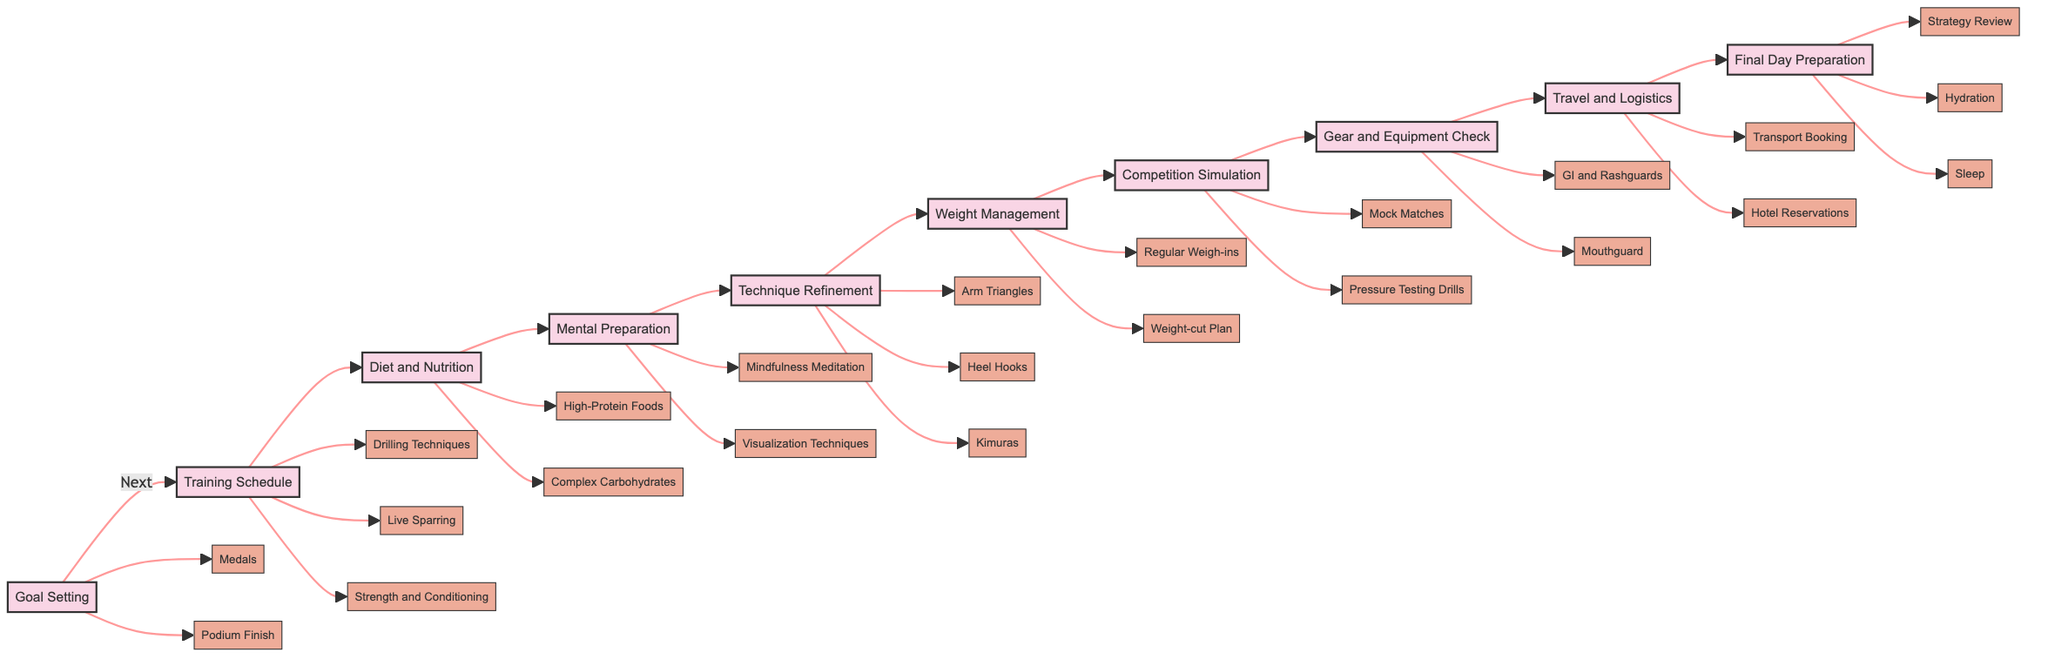What is the first step in preparing for a grappling tournament? The diagram indicates that the first step is "Goal Setting", as it is the initial node in the flowchart and leads to the next step, "Training Schedule".
Answer: Goal Setting How many main steps are represented in the diagram? By counting the nodes connected in the main flow, there are ten primary steps in total, from "Goal Setting" to "Final Day Preparation".
Answer: Ten What are examples of entities under Technique Refinement? The diagram lists three specific techniques under "Technique Refinement", namely "Arm Triangles", "Heel Hooks", and "Kimuras".
Answer: Arm Triangles, Heel Hooks, Kimuras Which steps come before and after Weight Management? The diagram shows that "Technique Refinement" comes before "Weight Management", and "Competition Simulation" follows it directly.
Answer: Technique Refinement, Competition Simulation How does Mental Preparation contribute to the overall tournament preparation? "Mental Preparation" focuses on exercises that build mental resilience, which is a crucial aspect before moving to the technical aspects like "Technique Refinement" and practical aspects like "Weight Management". This indicates its supportive role in enhancing performance.
Answer: Builds resilience What is involved in the Final Day Preparation? The diagram specifies three key activities: "Strategy Review," "Hydration," and "Sleep," all aimed at ensuring optimal readiness for the tournament day itself.
Answer: Strategy Review, Hydration, Sleep Which step involves monitoring your weight? The step dedicated to monitoring weight is "Weight Management", which describes activities like "Regular Weigh-ins" and "Weight-cut Plan".
Answer: Weight Management How does the flowchart represent the relationship between Diet and Nutrition and Mental Preparation? The flowchart shows that "Diet and Nutrition" directly leads to "Mental Preparation", indicating that proper nutrition supports mental readiness and resilience during tournament preparation.
Answer: Directly connected What step addresses travel arrangements for the tournament? The "Travel and Logistics" step is concerned with planning transport and accommodation for the tournament venue, as indicated by the entities listed under that node.
Answer: Travel and Logistics 